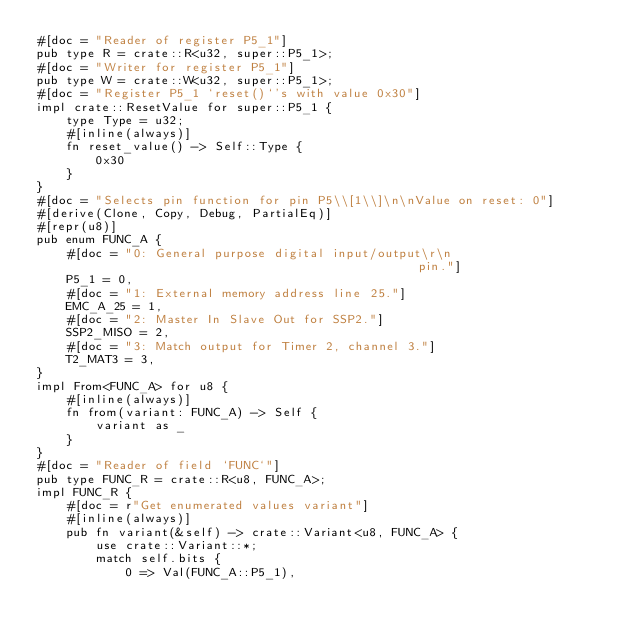<code> <loc_0><loc_0><loc_500><loc_500><_Rust_>#[doc = "Reader of register P5_1"]
pub type R = crate::R<u32, super::P5_1>;
#[doc = "Writer for register P5_1"]
pub type W = crate::W<u32, super::P5_1>;
#[doc = "Register P5_1 `reset()`'s with value 0x30"]
impl crate::ResetValue for super::P5_1 {
    type Type = u32;
    #[inline(always)]
    fn reset_value() -> Self::Type {
        0x30
    }
}
#[doc = "Selects pin function for pin P5\\[1\\]\n\nValue on reset: 0"]
#[derive(Clone, Copy, Debug, PartialEq)]
#[repr(u8)]
pub enum FUNC_A {
    #[doc = "0: General purpose digital input/output\r\n                                            pin."]
    P5_1 = 0,
    #[doc = "1: External memory address line 25."]
    EMC_A_25 = 1,
    #[doc = "2: Master In Slave Out for SSP2."]
    SSP2_MISO = 2,
    #[doc = "3: Match output for Timer 2, channel 3."]
    T2_MAT3 = 3,
}
impl From<FUNC_A> for u8 {
    #[inline(always)]
    fn from(variant: FUNC_A) -> Self {
        variant as _
    }
}
#[doc = "Reader of field `FUNC`"]
pub type FUNC_R = crate::R<u8, FUNC_A>;
impl FUNC_R {
    #[doc = r"Get enumerated values variant"]
    #[inline(always)]
    pub fn variant(&self) -> crate::Variant<u8, FUNC_A> {
        use crate::Variant::*;
        match self.bits {
            0 => Val(FUNC_A::P5_1),</code> 